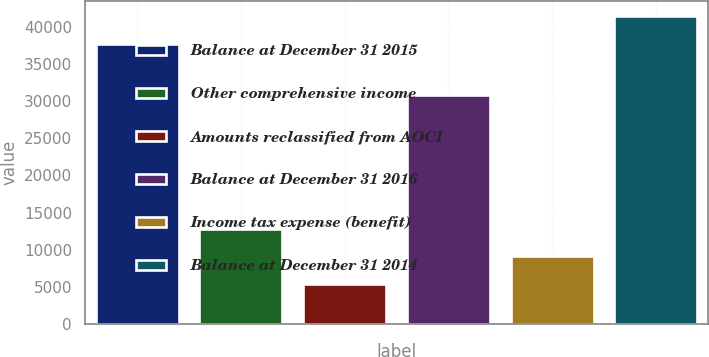Convert chart. <chart><loc_0><loc_0><loc_500><loc_500><bar_chart><fcel>Balance at December 31 2015<fcel>Other comprehensive income<fcel>Amounts reclassified from AOCI<fcel>Balance at December 31 2016<fcel>Income tax expense (benefit)<fcel>Balance at December 31 2014<nl><fcel>37789<fcel>12733<fcel>5415<fcel>30803<fcel>9074<fcel>41448<nl></chart> 